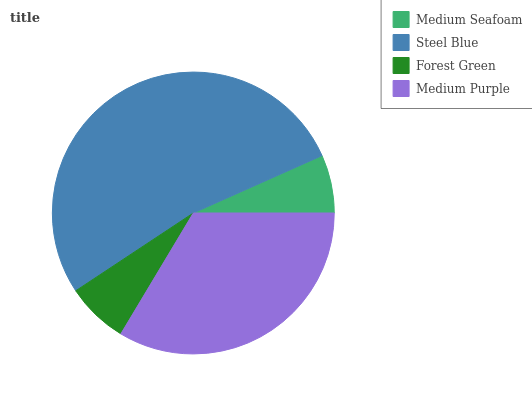Is Medium Seafoam the minimum?
Answer yes or no. Yes. Is Steel Blue the maximum?
Answer yes or no. Yes. Is Forest Green the minimum?
Answer yes or no. No. Is Forest Green the maximum?
Answer yes or no. No. Is Steel Blue greater than Forest Green?
Answer yes or no. Yes. Is Forest Green less than Steel Blue?
Answer yes or no. Yes. Is Forest Green greater than Steel Blue?
Answer yes or no. No. Is Steel Blue less than Forest Green?
Answer yes or no. No. Is Medium Purple the high median?
Answer yes or no. Yes. Is Forest Green the low median?
Answer yes or no. Yes. Is Medium Seafoam the high median?
Answer yes or no. No. Is Medium Seafoam the low median?
Answer yes or no. No. 